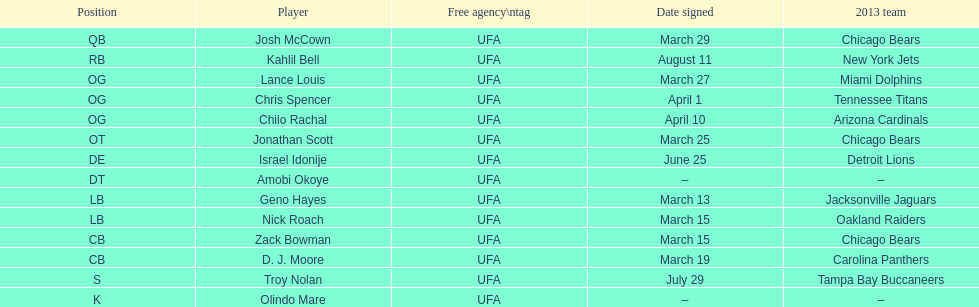Last name is also a first name beginning with "n" Troy Nolan. 